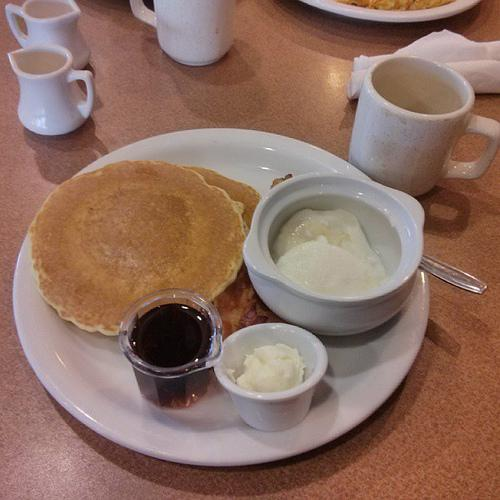Question: where is the plate?
Choices:
A. On the ground.
B. On a tray.
C. In the sink.
D. On the table.
Answer with the letter. Answer: D Question: what is on the table?
Choices:
A. The plate.
B. The fork.
C. The knife.
D. The spoon.
Answer with the letter. Answer: A Question: what color is the table?
Choices:
A. Brown.
B. White.
C. Black.
D. Red.
Answer with the letter. Answer: A 